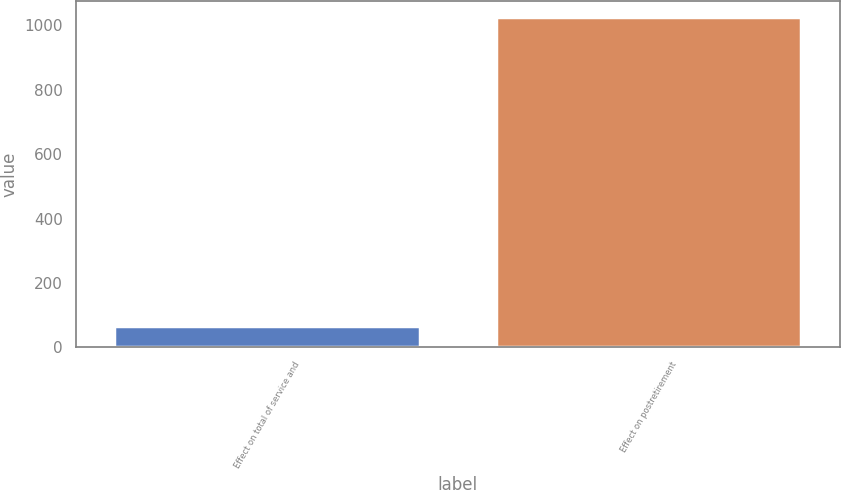Convert chart. <chart><loc_0><loc_0><loc_500><loc_500><bar_chart><fcel>Effect on total of service and<fcel>Effect on postretirement<nl><fcel>67<fcel>1025<nl></chart> 